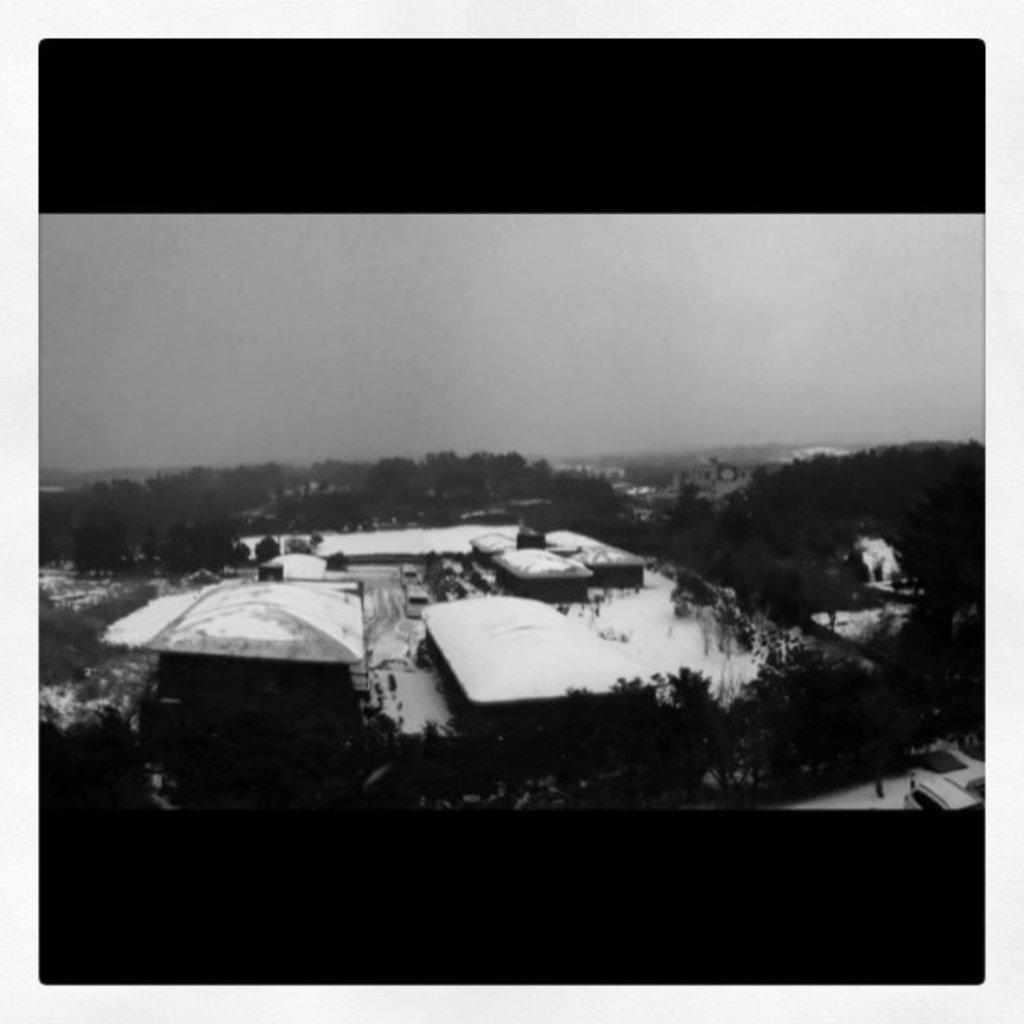What is the color scheme of the image? The image is black and white. What is the setting of the image? The image shows an outside view. What structures can be seen in the middle of the image? There are sheds in the middle of the image. What is visible in the background of the image? There is a sky visible in the background of the image. How many sisters are present in the image? There are no sisters present in the image, as it features an outside view with sheds and a sky. 